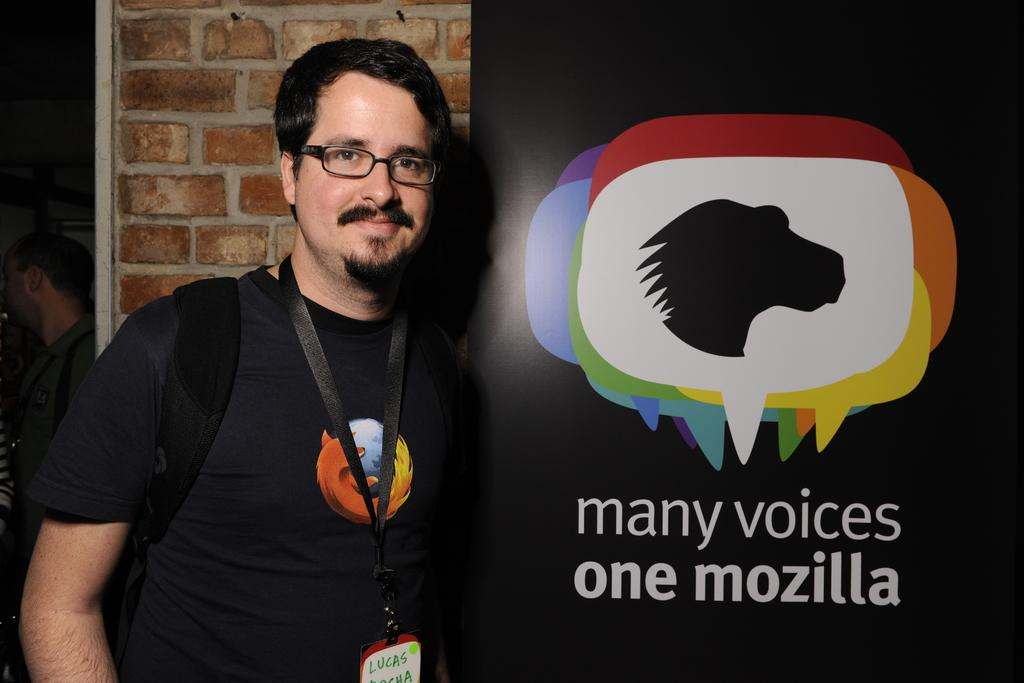What is the person in the image holding? The person in the image is holding a bag. What can be seen beside the person holding the bag? The person is standing beside a board. Can you describe the other person visible in the image? There is another person visible in the background of the image. What thought is the person holding the bag having in the image? There is no way to determine the person's thoughts from the image. How many boys are visible in the image? The provided facts do not mention the gender of the people in the image, so we cannot determine if any of them are boys. 